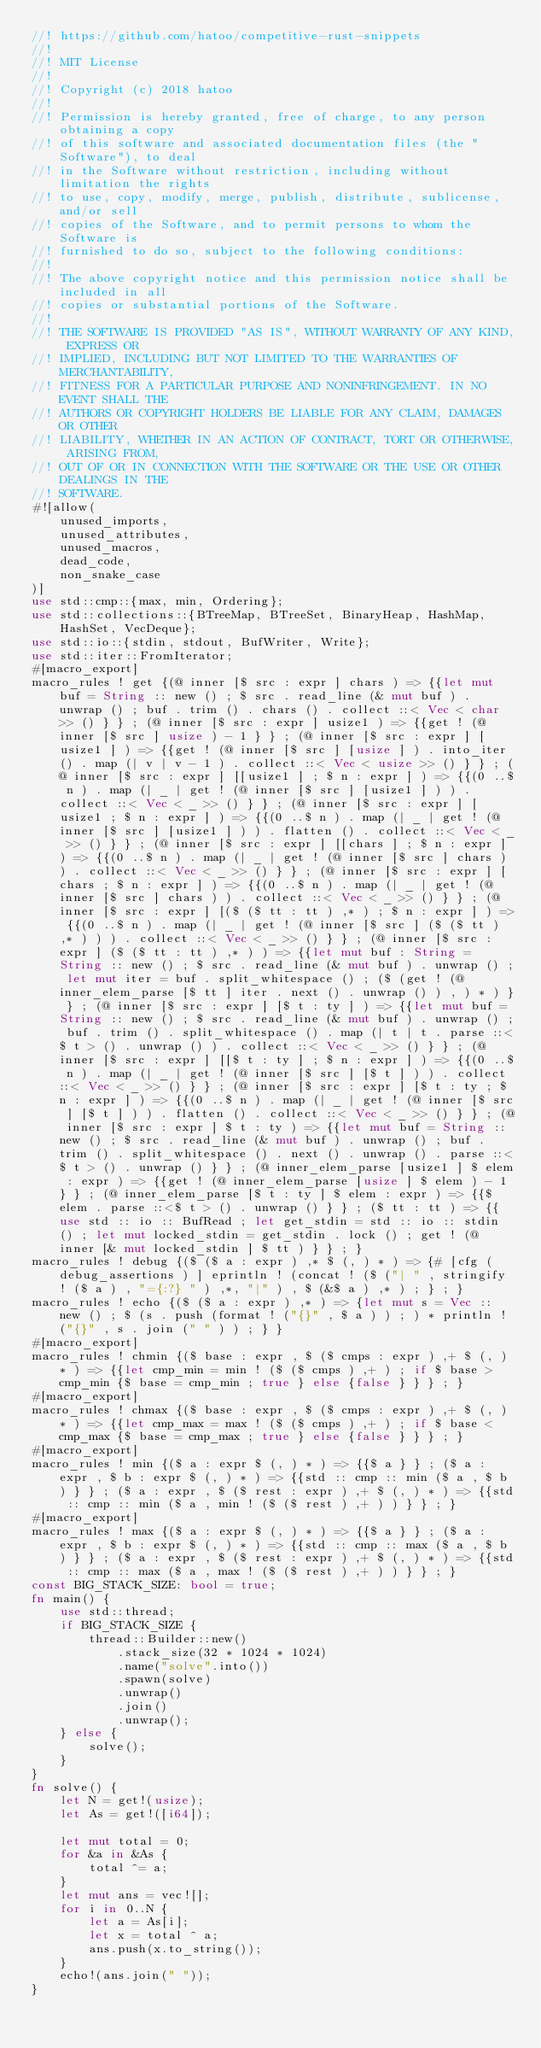Convert code to text. <code><loc_0><loc_0><loc_500><loc_500><_Rust_>//! https://github.com/hatoo/competitive-rust-snippets
//!
//! MIT License
//!
//! Copyright (c) 2018 hatoo
//!
//! Permission is hereby granted, free of charge, to any person obtaining a copy
//! of this software and associated documentation files (the "Software"), to deal
//! in the Software without restriction, including without limitation the rights
//! to use, copy, modify, merge, publish, distribute, sublicense, and/or sell
//! copies of the Software, and to permit persons to whom the Software is
//! furnished to do so, subject to the following conditions:
//!
//! The above copyright notice and this permission notice shall be included in all
//! copies or substantial portions of the Software.
//!
//! THE SOFTWARE IS PROVIDED "AS IS", WITHOUT WARRANTY OF ANY KIND, EXPRESS OR
//! IMPLIED, INCLUDING BUT NOT LIMITED TO THE WARRANTIES OF MERCHANTABILITY,
//! FITNESS FOR A PARTICULAR PURPOSE AND NONINFRINGEMENT. IN NO EVENT SHALL THE
//! AUTHORS OR COPYRIGHT HOLDERS BE LIABLE FOR ANY CLAIM, DAMAGES OR OTHER
//! LIABILITY, WHETHER IN AN ACTION OF CONTRACT, TORT OR OTHERWISE, ARISING FROM,
//! OUT OF OR IN CONNECTION WITH THE SOFTWARE OR THE USE OR OTHER DEALINGS IN THE
//! SOFTWARE.
#![allow(
    unused_imports,
    unused_attributes,
    unused_macros,
    dead_code,
    non_snake_case
)]
use std::cmp::{max, min, Ordering};
use std::collections::{BTreeMap, BTreeSet, BinaryHeap, HashMap, HashSet, VecDeque};
use std::io::{stdin, stdout, BufWriter, Write};
use std::iter::FromIterator;
#[macro_export]
macro_rules ! get {(@ inner [$ src : expr ] chars ) => {{let mut buf = String :: new () ; $ src . read_line (& mut buf ) . unwrap () ; buf . trim () . chars () . collect ::< Vec < char >> () } } ; (@ inner [$ src : expr ] usize1 ) => {{get ! (@ inner [$ src ] usize ) - 1 } } ; (@ inner [$ src : expr ] [usize1 ] ) => {{get ! (@ inner [$ src ] [usize ] ) . into_iter () . map (| v | v - 1 ) . collect ::< Vec < usize >> () } } ; (@ inner [$ src : expr ] [[usize1 ] ; $ n : expr ] ) => {{(0 ..$ n ) . map (| _ | get ! (@ inner [$ src ] [usize1 ] ) ) . collect ::< Vec < _ >> () } } ; (@ inner [$ src : expr ] [usize1 ; $ n : expr ] ) => {{(0 ..$ n ) . map (| _ | get ! (@ inner [$ src ] [usize1 ] ) ) . flatten () . collect ::< Vec < _ >> () } } ; (@ inner [$ src : expr ] [[chars ] ; $ n : expr ] ) => {{(0 ..$ n ) . map (| _ | get ! (@ inner [$ src ] chars ) ) . collect ::< Vec < _ >> () } } ; (@ inner [$ src : expr ] [chars ; $ n : expr ] ) => {{(0 ..$ n ) . map (| _ | get ! (@ inner [$ src ] chars ) ) . collect ::< Vec < _ >> () } } ; (@ inner [$ src : expr ] [($ ($ tt : tt ) ,* ) ; $ n : expr ] ) => {{(0 ..$ n ) . map (| _ | get ! (@ inner [$ src ] ($ ($ tt ) ,* ) ) ) . collect ::< Vec < _ >> () } } ; (@ inner [$ src : expr ] ($ ($ tt : tt ) ,* ) ) => {{let mut buf : String = String :: new () ; $ src . read_line (& mut buf ) . unwrap () ; let mut iter = buf . split_whitespace () ; ($ (get ! (@ inner_elem_parse [$ tt ] iter . next () . unwrap () ) , ) * ) } } ; (@ inner [$ src : expr ] [$ t : ty ] ) => {{let mut buf = String :: new () ; $ src . read_line (& mut buf ) . unwrap () ; buf . trim () . split_whitespace () . map (| t | t . parse ::<$ t > () . unwrap () ) . collect ::< Vec < _ >> () } } ; (@ inner [$ src : expr ] [[$ t : ty ] ; $ n : expr ] ) => {{(0 ..$ n ) . map (| _ | get ! (@ inner [$ src ] [$ t ] ) ) . collect ::< Vec < _ >> () } } ; (@ inner [$ src : expr ] [$ t : ty ; $ n : expr ] ) => {{(0 ..$ n ) . map (| _ | get ! (@ inner [$ src ] [$ t ] ) ) . flatten () . collect ::< Vec < _ >> () } } ; (@ inner [$ src : expr ] $ t : ty ) => {{let mut buf = String :: new () ; $ src . read_line (& mut buf ) . unwrap () ; buf . trim () . split_whitespace () . next () . unwrap () . parse ::<$ t > () . unwrap () } } ; (@ inner_elem_parse [usize1 ] $ elem : expr ) => {{get ! (@ inner_elem_parse [usize ] $ elem ) - 1 } } ; (@ inner_elem_parse [$ t : ty ] $ elem : expr ) => {{$ elem . parse ::<$ t > () . unwrap () } } ; ($ tt : tt ) => {{use std :: io :: BufRead ; let get_stdin = std :: io :: stdin () ; let mut locked_stdin = get_stdin . lock () ; get ! (@ inner [& mut locked_stdin ] $ tt ) } } ; }
macro_rules ! debug {($ ($ a : expr ) ,* $ (, ) * ) => {# [cfg (debug_assertions ) ] eprintln ! (concat ! ($ ("| " , stringify ! ($ a ) , "={:?} " ) ,*, "|" ) , $ (&$ a ) ,* ) ; } ; }
macro_rules ! echo {($ ($ a : expr ) ,* ) => {let mut s = Vec :: new () ; $ (s . push (format ! ("{}" , $ a ) ) ; ) * println ! ("{}" , s . join (" " ) ) ; } }
#[macro_export]
macro_rules ! chmin {($ base : expr , $ ($ cmps : expr ) ,+ $ (, ) * ) => {{let cmp_min = min ! ($ ($ cmps ) ,+ ) ; if $ base > cmp_min {$ base = cmp_min ; true } else {false } } } ; }
#[macro_export]
macro_rules ! chmax {($ base : expr , $ ($ cmps : expr ) ,+ $ (, ) * ) => {{let cmp_max = max ! ($ ($ cmps ) ,+ ) ; if $ base < cmp_max {$ base = cmp_max ; true } else {false } } } ; }
#[macro_export]
macro_rules ! min {($ a : expr $ (, ) * ) => {{$ a } } ; ($ a : expr , $ b : expr $ (, ) * ) => {{std :: cmp :: min ($ a , $ b ) } } ; ($ a : expr , $ ($ rest : expr ) ,+ $ (, ) * ) => {{std :: cmp :: min ($ a , min ! ($ ($ rest ) ,+ ) ) } } ; }
#[macro_export]
macro_rules ! max {($ a : expr $ (, ) * ) => {{$ a } } ; ($ a : expr , $ b : expr $ (, ) * ) => {{std :: cmp :: max ($ a , $ b ) } } ; ($ a : expr , $ ($ rest : expr ) ,+ $ (, ) * ) => {{std :: cmp :: max ($ a , max ! ($ ($ rest ) ,+ ) ) } } ; }
const BIG_STACK_SIZE: bool = true;
fn main() {
    use std::thread;
    if BIG_STACK_SIZE {
        thread::Builder::new()
            .stack_size(32 * 1024 * 1024)
            .name("solve".into())
            .spawn(solve)
            .unwrap()
            .join()
            .unwrap();
    } else {
        solve();
    }
}
fn solve() {
    let N = get!(usize);
    let As = get!([i64]);

    let mut total = 0;
    for &a in &As {
        total ^= a;
    }
    let mut ans = vec![];
    for i in 0..N {
        let a = As[i];
        let x = total ^ a;
        ans.push(x.to_string());
    }
    echo!(ans.join(" "));
}
</code> 